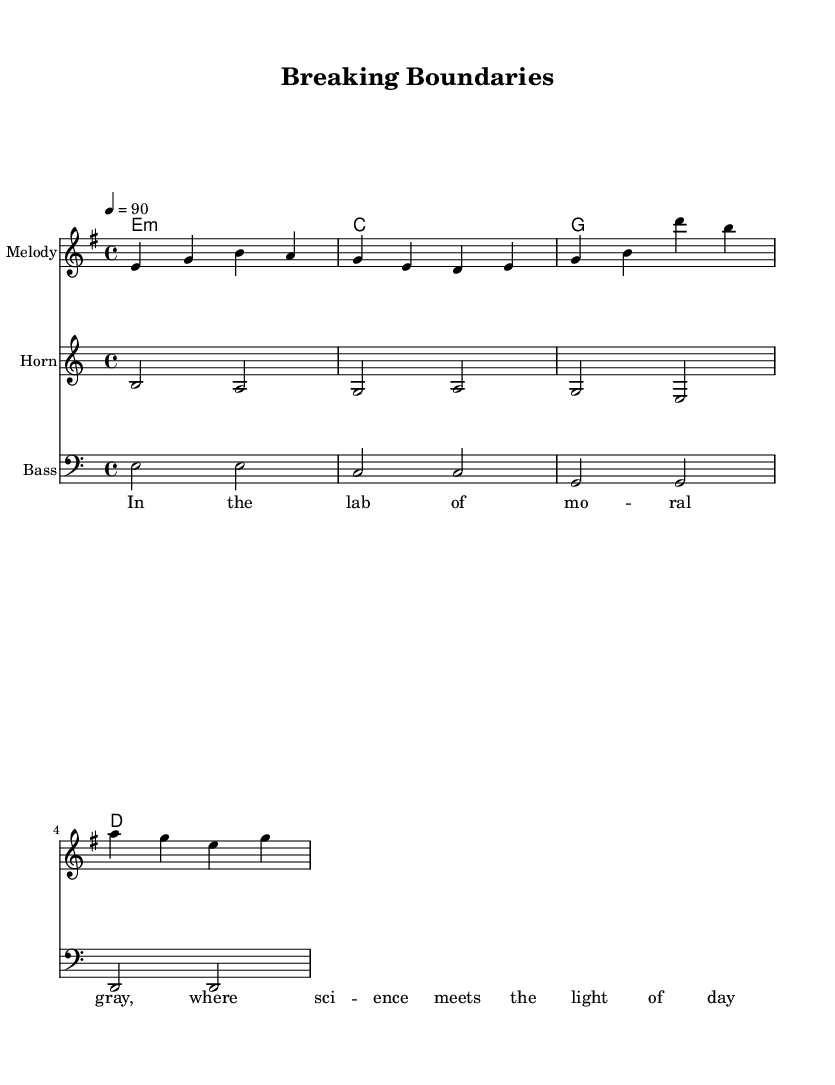What is the key signature of this music? The key signature is E minor, which contains one sharp (F#) that allows the scale to be centered around E as the tonic note.
Answer: E minor What is the time signature of the piece? The time signature shows "4/4," meaning there are four beats in each measure, and the quarter note receives one beat.
Answer: 4/4 What is the tempo marking indicated in the score? The tempo marking is indicated as "4 = 90," which means there are 90 beats per minute, suggesting a moderate pace for the performance.
Answer: 90 How many melodic phrases are there in the melody? The melody contains two phrases (the first phrase ends with 'g' and the second phrase starts with 'g'), showing a clear structure of musical ideas.
Answer: 2 What instrumentation is used in this piece? The piece includes a melody, bass, and horn, as indicated by the separate staves for each instrument in the score.
Answer: Melody, Bass, Horn Which note is the tonic of the piece? The tonic of the piece is E, which is the root note of the E minor scale, and appears prominently in both the melody and harmonies.
Answer: E 